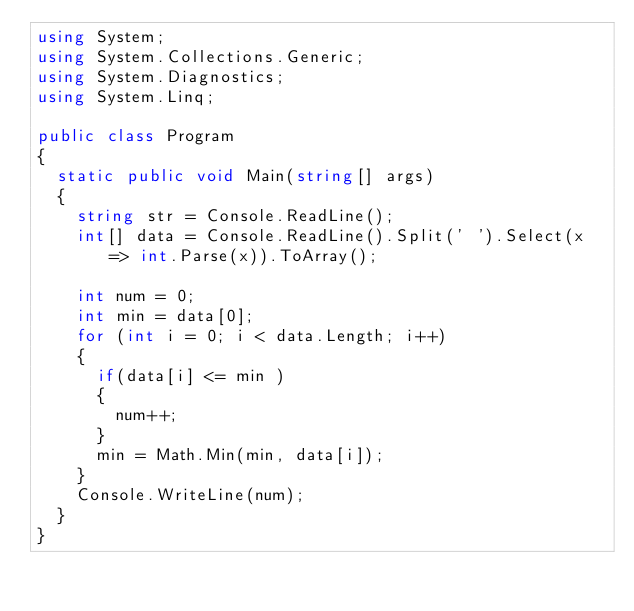Convert code to text. <code><loc_0><loc_0><loc_500><loc_500><_C#_>using System;
using System.Collections.Generic;
using System.Diagnostics;
using System.Linq;

public class Program
{
	static public void Main(string[] args)
	{
		string str = Console.ReadLine();
		int[] data = Console.ReadLine().Split(' ').Select(x => int.Parse(x)).ToArray();

		int num = 0;
		int min = data[0];
		for (int i = 0; i < data.Length; i++)
		{
			if(data[i] <= min )
			{
				num++;
			}
			min = Math.Min(min, data[i]);
		}
		Console.WriteLine(num);
	}
}</code> 